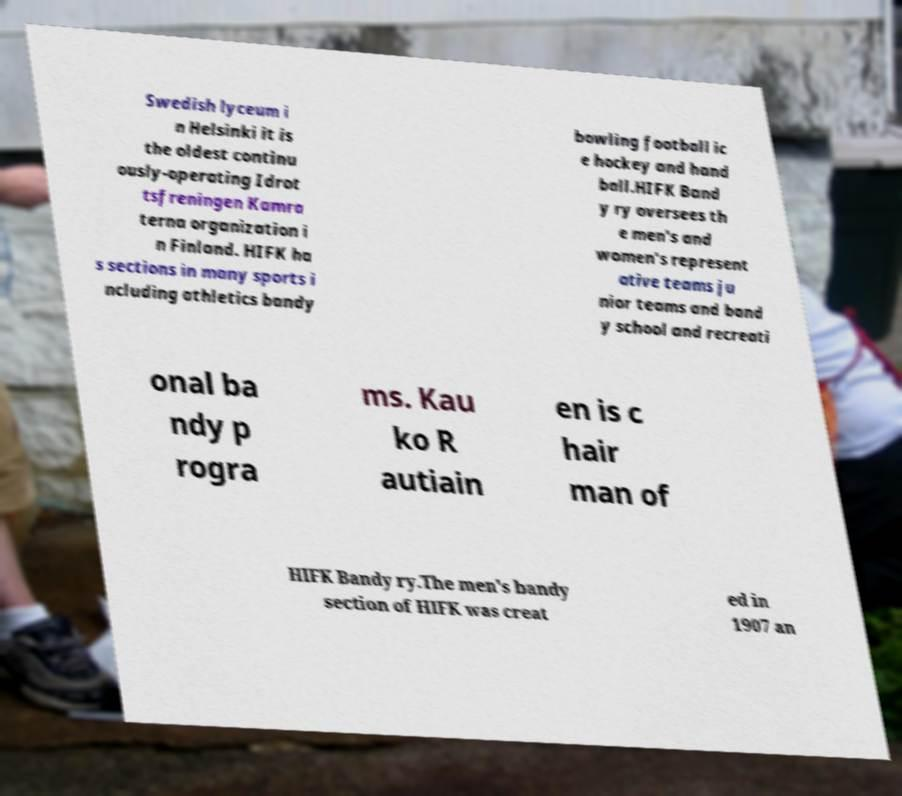Could you extract and type out the text from this image? Swedish lyceum i n Helsinki it is the oldest continu ously-operating Idrot tsfreningen Kamra terna organization i n Finland. HIFK ha s sections in many sports i ncluding athletics bandy bowling football ic e hockey and hand ball.HIFK Band y ry oversees th e men's and women's represent ative teams ju nior teams and band y school and recreati onal ba ndy p rogra ms. Kau ko R autiain en is c hair man of HIFK Bandy ry.The men's bandy section of HIFK was creat ed in 1907 an 